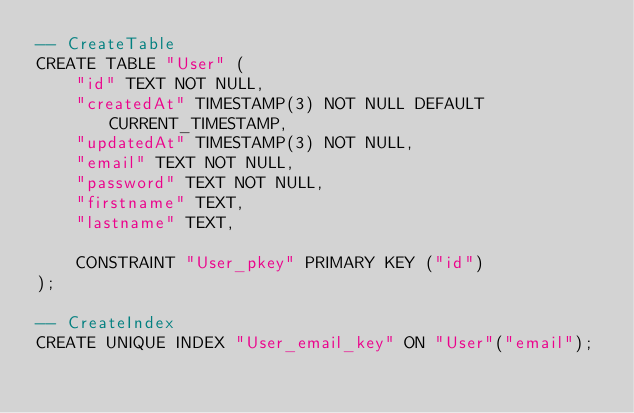Convert code to text. <code><loc_0><loc_0><loc_500><loc_500><_SQL_>-- CreateTable
CREATE TABLE "User" (
    "id" TEXT NOT NULL,
    "createdAt" TIMESTAMP(3) NOT NULL DEFAULT CURRENT_TIMESTAMP,
    "updatedAt" TIMESTAMP(3) NOT NULL,
    "email" TEXT NOT NULL,
    "password" TEXT NOT NULL,
    "firstname" TEXT,
    "lastname" TEXT,

    CONSTRAINT "User_pkey" PRIMARY KEY ("id")
);

-- CreateIndex
CREATE UNIQUE INDEX "User_email_key" ON "User"("email");
</code> 